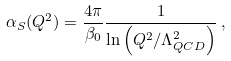<formula> <loc_0><loc_0><loc_500><loc_500>\alpha _ { S } ( Q ^ { 2 } ) = \frac { 4 \pi } { \beta _ { 0 } } \frac { 1 } { \ln \left ( Q ^ { 2 } / \Lambda _ { Q C D } ^ { 2 } \right ) } \, ,</formula> 